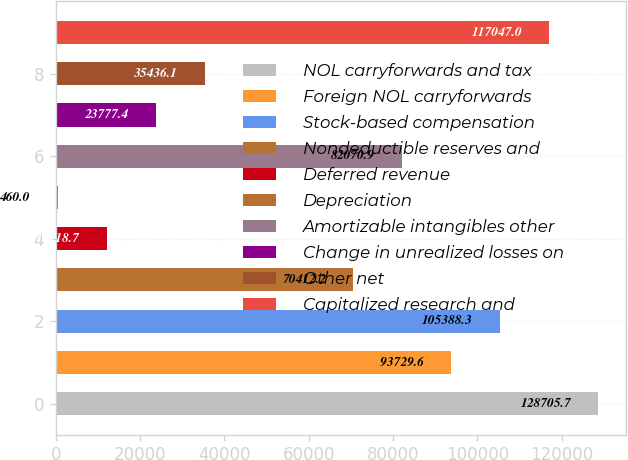<chart> <loc_0><loc_0><loc_500><loc_500><bar_chart><fcel>NOL carryforwards and tax<fcel>Foreign NOL carryforwards<fcel>Stock-based compensation<fcel>Nondeductible reserves and<fcel>Deferred revenue<fcel>Depreciation<fcel>Amortizable intangibles other<fcel>Change in unrealized losses on<fcel>Other net<fcel>Capitalized research and<nl><fcel>128706<fcel>93729.6<fcel>105388<fcel>70412.2<fcel>12118.7<fcel>460<fcel>82070.9<fcel>23777.4<fcel>35436.1<fcel>117047<nl></chart> 